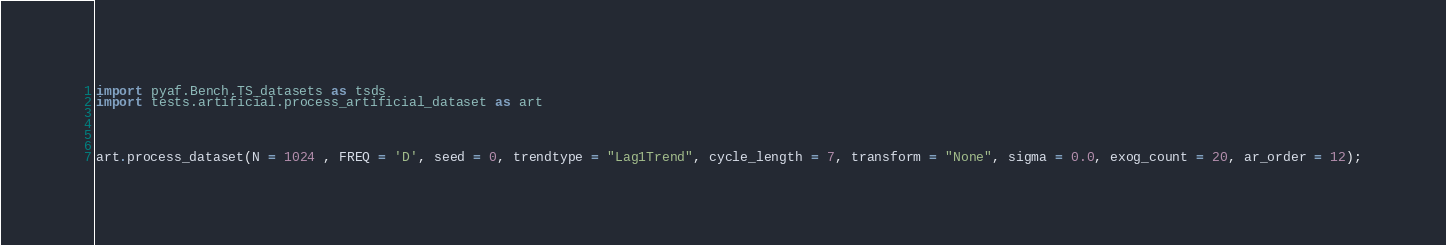Convert code to text. <code><loc_0><loc_0><loc_500><loc_500><_Python_>import pyaf.Bench.TS_datasets as tsds
import tests.artificial.process_artificial_dataset as art




art.process_dataset(N = 1024 , FREQ = 'D', seed = 0, trendtype = "Lag1Trend", cycle_length = 7, transform = "None", sigma = 0.0, exog_count = 20, ar_order = 12);</code> 